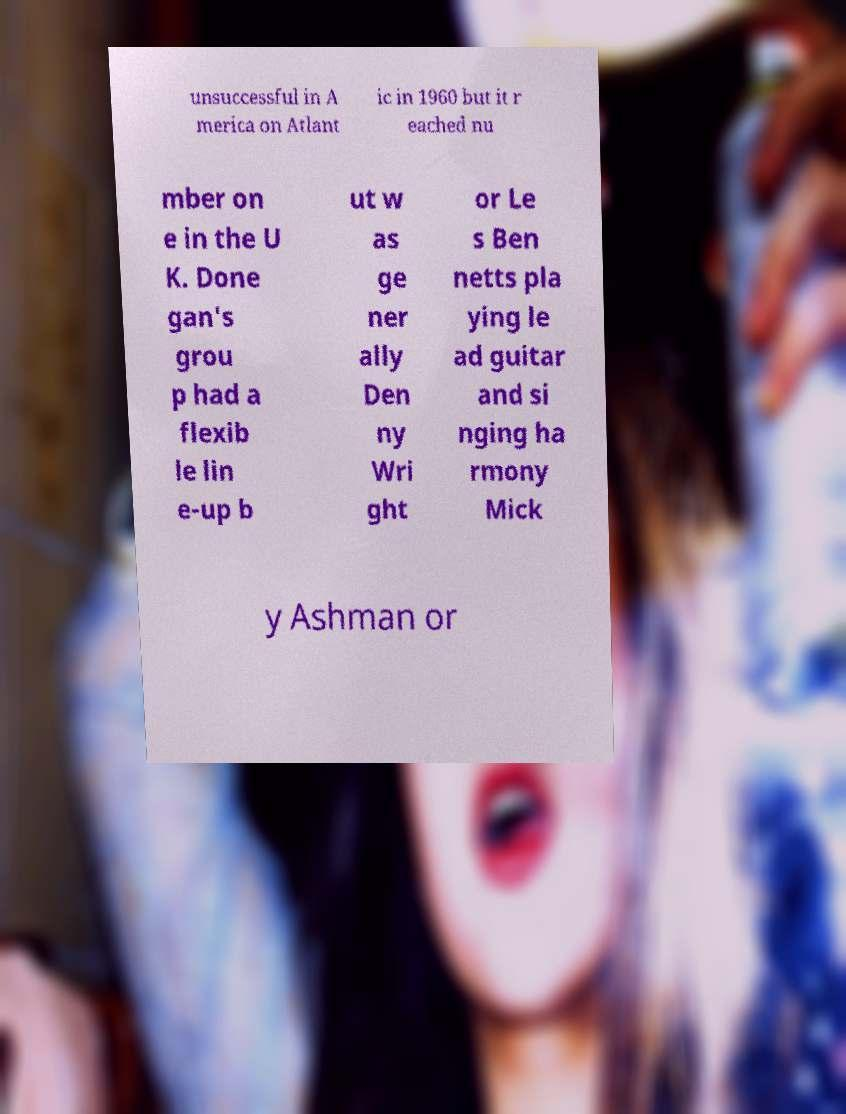Could you assist in decoding the text presented in this image and type it out clearly? unsuccessful in A merica on Atlant ic in 1960 but it r eached nu mber on e in the U K. Done gan's grou p had a flexib le lin e-up b ut w as ge ner ally Den ny Wri ght or Le s Ben netts pla ying le ad guitar and si nging ha rmony Mick y Ashman or 